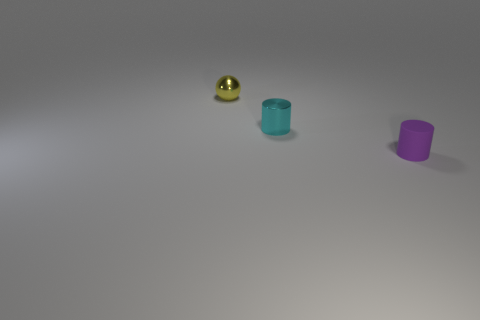Is there anything else that is the same material as the purple thing?
Offer a terse response. No. What is the size of the metal thing that is on the right side of the small thing that is behind the metallic thing that is on the right side of the tiny yellow sphere?
Make the answer very short. Small. There is a cylinder that is behind the purple rubber object; is it the same color as the rubber cylinder?
Make the answer very short. No. There is another object that is the same shape as the small cyan object; what size is it?
Make the answer very short. Small. What number of objects are either small cylinders behind the rubber thing or things to the right of the small yellow thing?
Give a very brief answer. 2. There is a tiny thing behind the metal object that is in front of the shiny ball; what is its shape?
Offer a terse response. Sphere. Are there any other things that are the same color as the tiny matte cylinder?
Your answer should be very brief. No. How many things are either tiny purple matte things or brown rubber cubes?
Ensure brevity in your answer.  1. Are there any other gray cylinders of the same size as the rubber cylinder?
Your response must be concise. No. What is the shape of the small cyan metal object?
Offer a very short reply. Cylinder. 